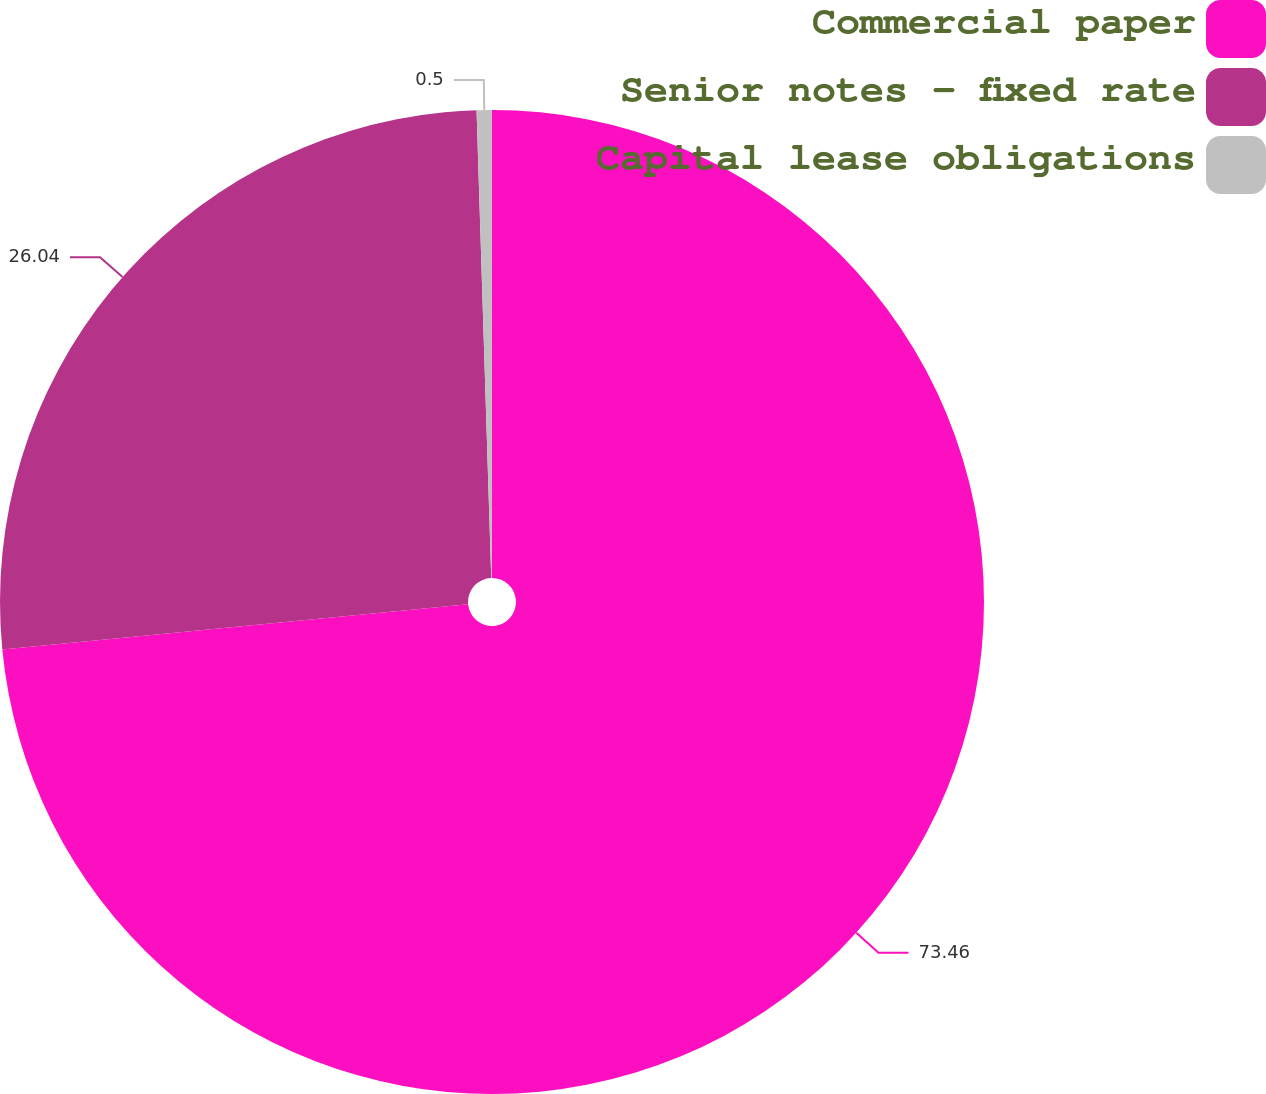<chart> <loc_0><loc_0><loc_500><loc_500><pie_chart><fcel>Commercial paper<fcel>Senior notes - fixed rate<fcel>Capital lease obligations<nl><fcel>73.47%<fcel>26.04%<fcel>0.5%<nl></chart> 